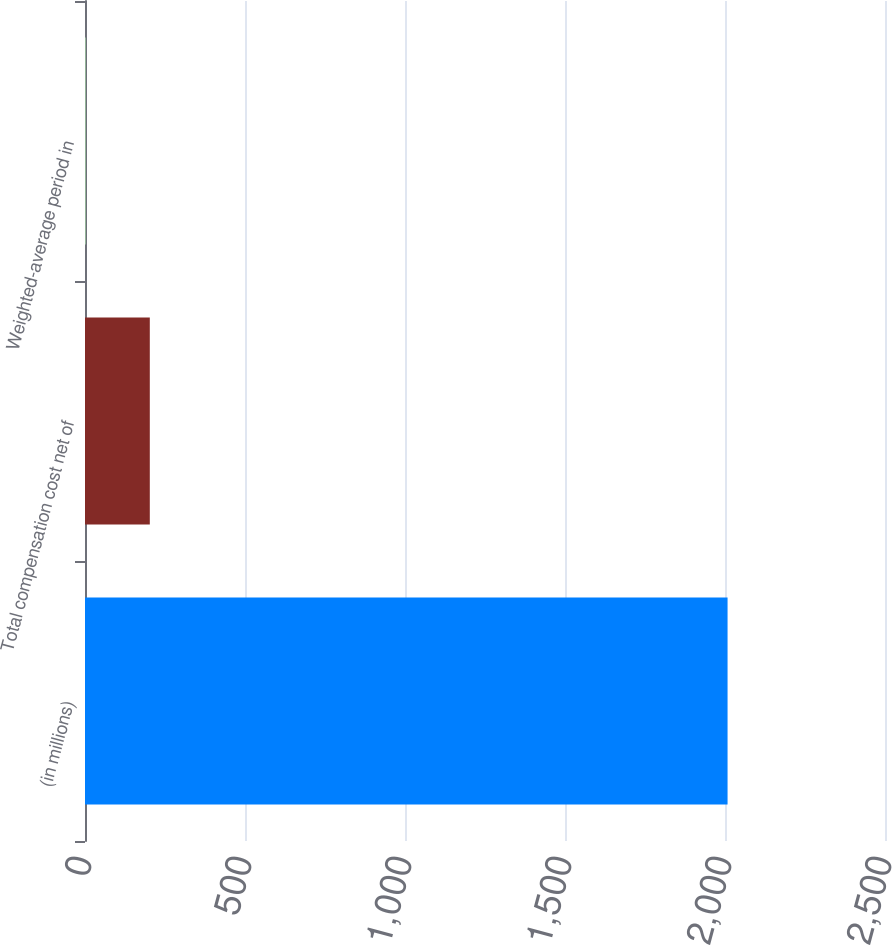Convert chart to OTSL. <chart><loc_0><loc_0><loc_500><loc_500><bar_chart><fcel>(in millions)<fcel>Total compensation cost net of<fcel>Weighted-average period in<nl><fcel>2008<fcel>202.51<fcel>1.9<nl></chart> 